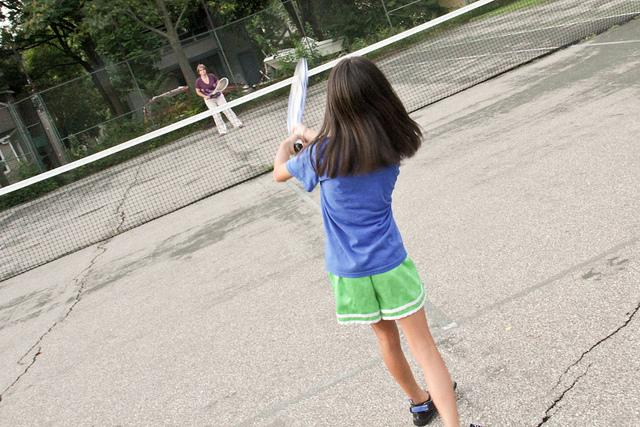Where does the girl want to hit the ball?

Choices:
A) behind net
B) under net
C) up
D) over net over net 